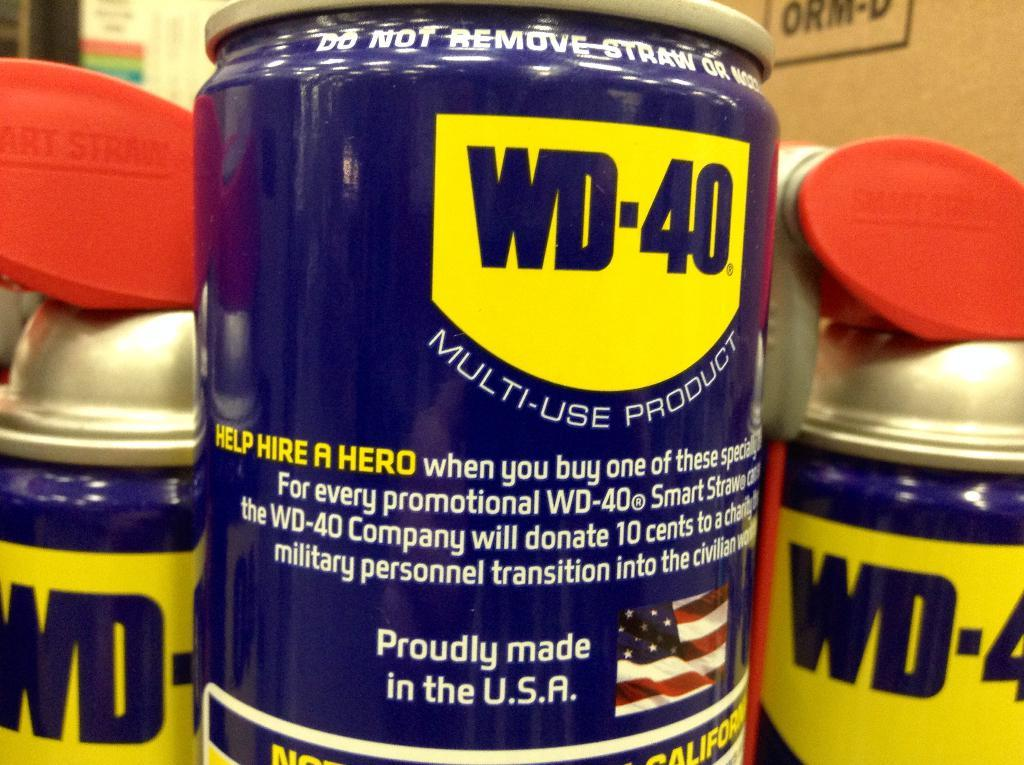<image>
Present a compact description of the photo's key features. a zoom in of the side of cans of WD-40. 